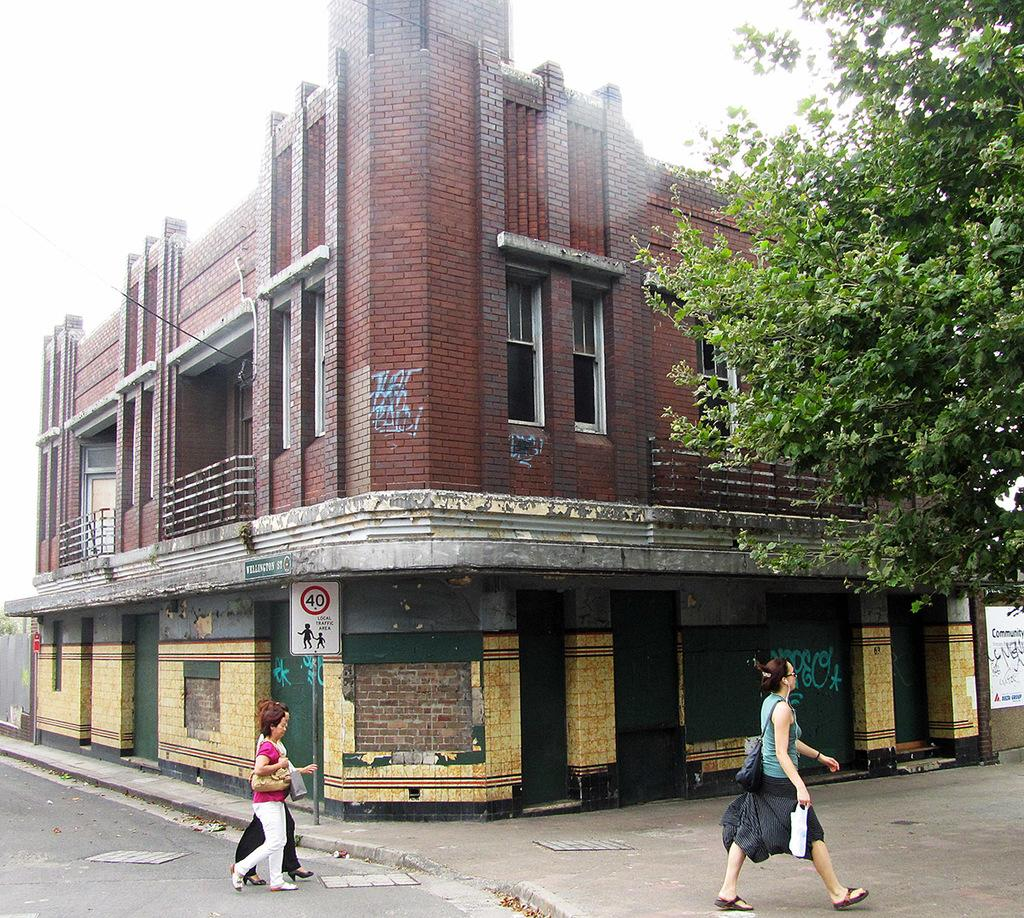What type of structures are present in the image? The image contains buildings. What is located at the bottom of the image? There is a road at the bottom of the image. What are the people in the image doing? Three persons are walking on the road. What can be seen to the right of the image? There is a tree to the right of the image. What is the color of the building in the image? The building is in brown color. How many knees are visible on the persons walking in the image? It is impossible to determine the number of knees visible on the persons walking in the image, as the image does not provide a clear view of their legs. 